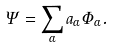<formula> <loc_0><loc_0><loc_500><loc_500>\Psi = \sum _ { \alpha } a _ { \alpha } \Phi _ { \alpha } .</formula> 